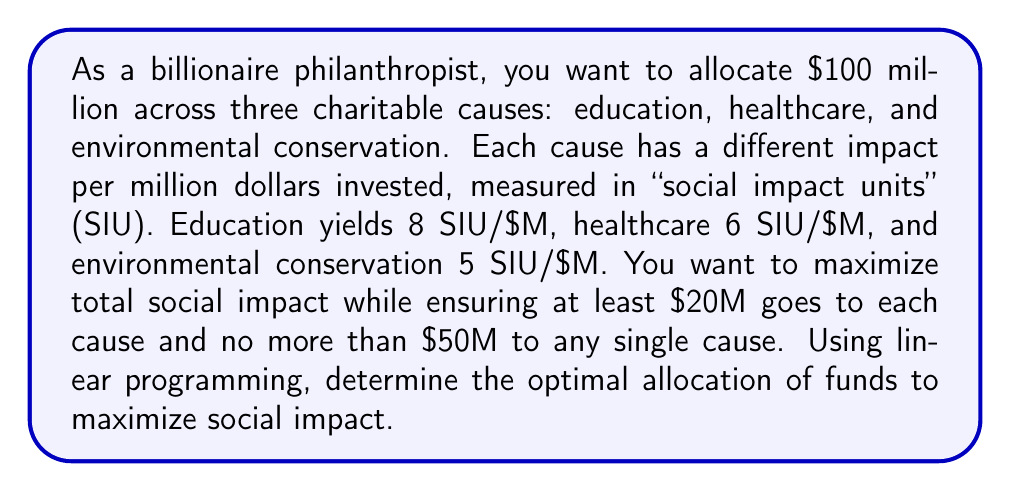Provide a solution to this math problem. Let's approach this step-by-step using linear programming:

1) Define variables:
   Let $x_1$, $x_2$, and $x_3$ represent the millions of dollars allocated to education, healthcare, and environmental conservation, respectively.

2) Objective function:
   Maximize $Z = 8x_1 + 6x_2 + 5x_3$ (total social impact)

3) Constraints:
   a) Total budget: $x_1 + x_2 + x_3 = 100$
   b) Minimum allocation: $x_1 \geq 20$, $x_2 \geq 20$, $x_3 \geq 20$
   c) Maximum allocation: $x_1 \leq 50$, $x_2 \leq 50$, $x_3 \leq 50$
   d) Non-negativity: $x_1, x_2, x_3 \geq 0$

4) Set up the linear program:

   Maximize $Z = 8x_1 + 6x_2 + 5x_3$
   Subject to:
   $$\begin{align}
   x_1 + x_2 + x_3 &= 100 \\
   x_1 &\geq 20 \\
   x_2 &\geq 20 \\
   x_3 &\geq 20 \\
   x_1 &\leq 50 \\
   x_2 &\leq 50 \\
   x_3 &\leq 50 \\
   x_1, x_2, x_3 &\geq 0
   \end{align}$$

5) Solve using the simplex method or linear programming software.

6) The optimal solution is:
   $x_1 = 50$ (Education)
   $x_2 = 30$ (Healthcare)
   $x_3 = 20$ (Environmental Conservation)

7) The maximum social impact is:
   $Z = 8(50) + 6(30) + 5(20) = 400 + 180 + 100 = 680$ SIU

This allocation satisfies all constraints and maximizes the total social impact.
Answer: Education: $50M, Healthcare: $30M, Environmental Conservation: $20M; Total Impact: 680 SIU 